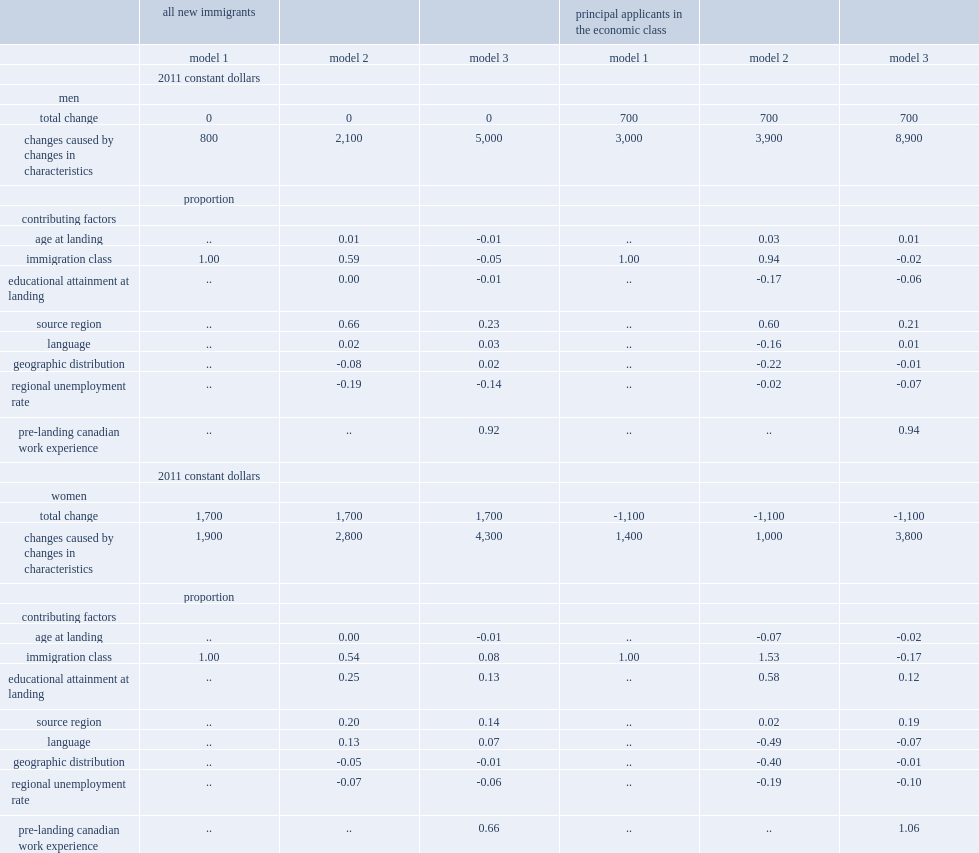How much entry earnings was tended to be raised by changes in all independent variables in model 2? 2800.0. What percentage of change in women's earnings was cuased by the pre-landing canadian work experience in model 3? 0.66. How much entry earnings for men pas did changes to all control variables tend to increase in model 3? 8900.0. How much entry earnings for female pas did changes in immigrant characteristics tend to increase in model 3? 3800.0. Write the full table. {'header': ['', 'all new immigrants', '', '', 'principal applicants in the economic class', '', ''], 'rows': [['', 'model 1', 'model 2', 'model 3', 'model 1', 'model 2', 'model 3'], ['', '2011 constant dollars', '', '', '', '', ''], ['men', '', '', '', '', '', ''], ['total change', '0', '0', '0', '700', '700', '700'], ['changes caused by changes in characteristics', '800', '2,100', '5,000', '3,000', '3,900', '8,900'], ['', 'proportion', '', '', '', '', ''], ['contributing factors', '', '', '', '', '', ''], ['age at landing', '..', '0.01', '-0.01', '..', '0.03', '0.01'], ['immigration class', '1.00', '0.59', '-0.05', '1.00', '0.94', '-0.02'], ['educational attainment at landing', '..', '0.00', '-0.01', '..', '-0.17', '-0.06'], ['source region', '..', '0.66', '0.23', '..', '0.60', '0.21'], ['language', '..', '0.02', '0.03', '..', '-0.16', '0.01'], ['geographic distribution', '..', '-0.08', '0.02', '..', '-0.22', '-0.01'], ['regional unemployment rate', '..', '-0.19', '-0.14', '..', '-0.02', '-0.07'], ['pre-landing canadian work experience', '..', '..', '0.92', '..', '..', '0.94'], ['', '2011 constant dollars', '', '', '', '', ''], ['women', '', '', '', '', '', ''], ['total change', '1,700', '1,700', '1,700', '-1,100', '-1,100', '-1,100'], ['changes caused by changes in characteristics', '1,900', '2,800', '4,300', '1,400', '1,000', '3,800'], ['', 'proportion', '', '', '', '', ''], ['contributing factors', '', '', '', '', '', ''], ['age at landing', '..', '0.00', '-0.01', '..', '-0.07', '-0.02'], ['immigration class', '1.00', '0.54', '0.08', '1.00', '1.53', '-0.17'], ['educational attainment at landing', '..', '0.25', '0.13', '..', '0.58', '0.12'], ['source region', '..', '0.20', '0.14', '..', '0.02', '0.19'], ['language', '..', '0.13', '0.07', '..', '-0.49', '-0.07'], ['geographic distribution', '..', '-0.05', '-0.01', '..', '-0.40', '-0.01'], ['regional unemployment rate', '..', '-0.07', '-0.06', '..', '-0.19', '-0.10'], ['pre-landing canadian work experience', '..', '..', '0.66', '..', '..', '1.06']]} 